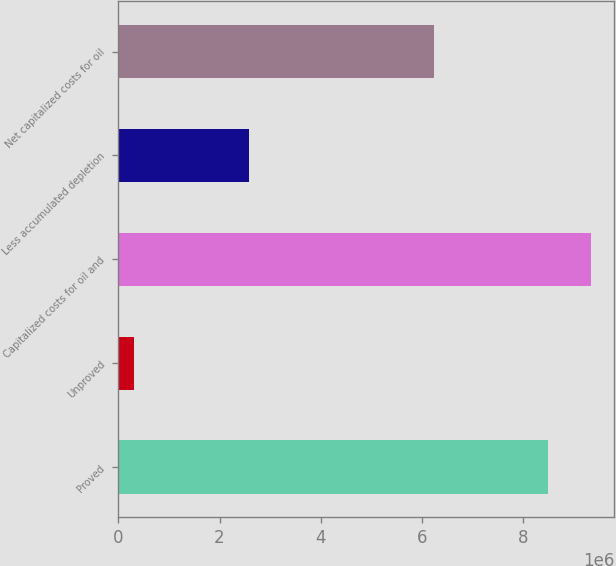<chart> <loc_0><loc_0><loc_500><loc_500><bar_chart><fcel>Proved<fcel>Unproved<fcel>Capitalized costs for oil and<fcel>Less accumulated depletion<fcel>Net capitalized costs for oil<nl><fcel>8.49925e+06<fcel>313881<fcel>9.34918e+06<fcel>2.57795e+06<fcel>6.23519e+06<nl></chart> 